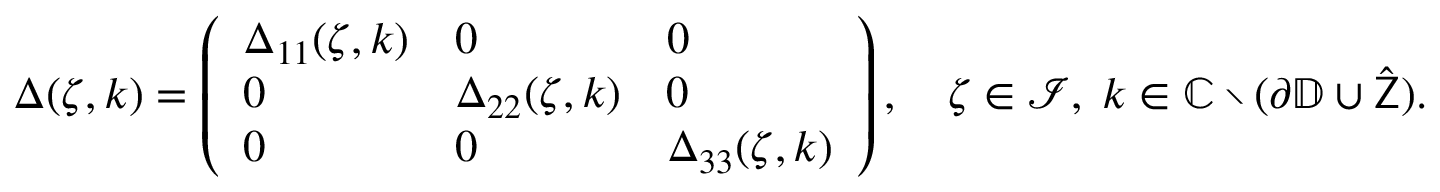<formula> <loc_0><loc_0><loc_500><loc_500>\begin{array} { r } { \Delta ( \zeta , k ) = \left ( \begin{array} { l l l } { \Delta _ { 1 1 } ( \zeta , k ) } & { 0 } & { 0 } \\ { 0 } & { \Delta _ { 2 2 } ( \zeta , k ) } & { 0 } \\ { 0 } & { 0 } & { \Delta _ { 3 3 } ( \zeta , k ) } \end{array} \right ) , \quad \zeta \in \mathcal { I } , \, k \in \mathbb { C } \ ( \partial \mathbb { D } \cup \hat { Z } ) . } \end{array}</formula> 